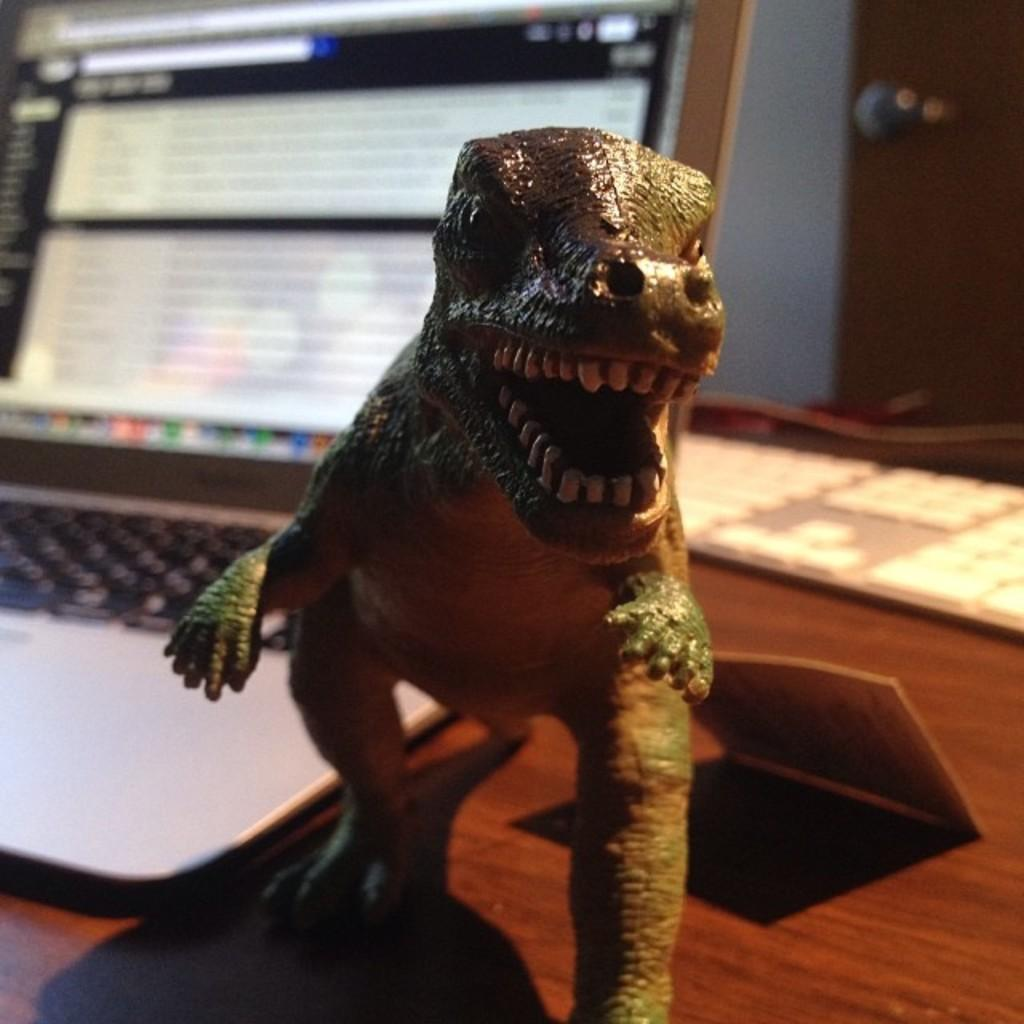What is the main subject in the image? There is a sculpture in the image. What electronic device is visible in the image? There is a laptop in the image. What other objects can be seen on the table in the image? There are other objects on the table in the image. What can be seen in the background of the image? There is a wall in the background of the image. How does the tent withstand the wind in the image? There is no tent or wind present in the image; it only features a sculpture, a laptop, and other objects on a table with a wall in the background. 